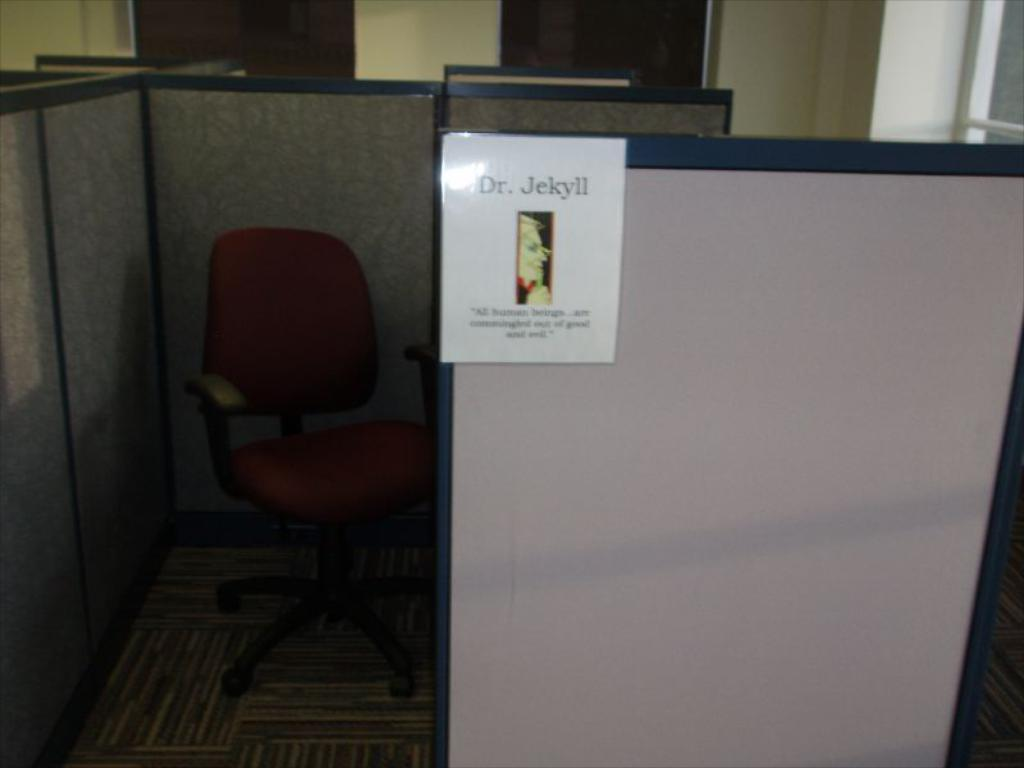<image>
Relay a brief, clear account of the picture shown. a picture on a cubicle that says Dr. Jekyll 